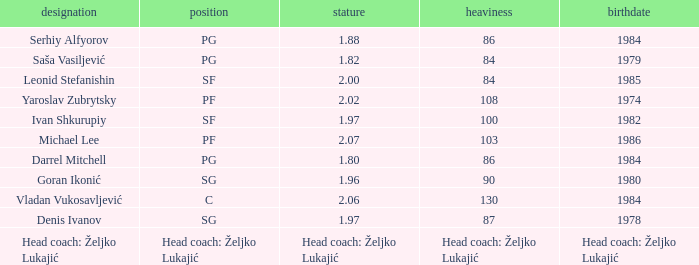What is the weight of the player with a height of 2.00m? 84.0. 